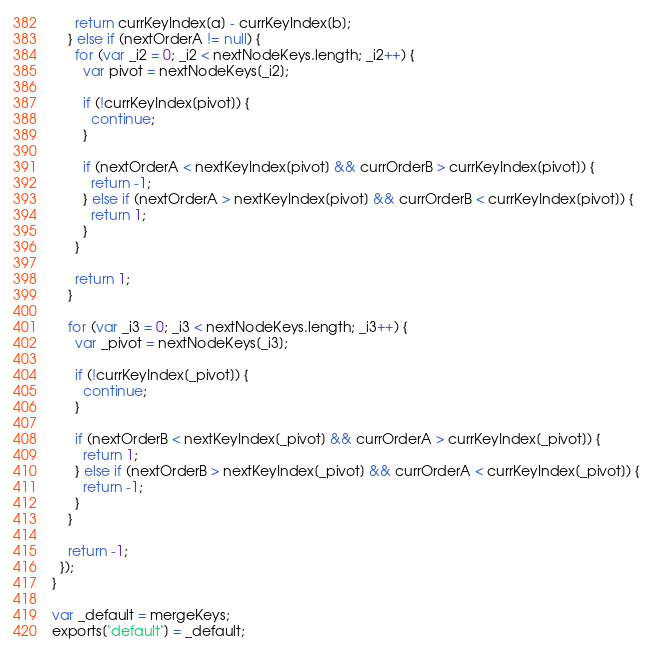Convert code to text. <code><loc_0><loc_0><loc_500><loc_500><_JavaScript_>      return currKeyIndex[a] - currKeyIndex[b];
    } else if (nextOrderA != null) {
      for (var _i2 = 0; _i2 < nextNodeKeys.length; _i2++) {
        var pivot = nextNodeKeys[_i2];

        if (!currKeyIndex[pivot]) {
          continue;
        }

        if (nextOrderA < nextKeyIndex[pivot] && currOrderB > currKeyIndex[pivot]) {
          return -1;
        } else if (nextOrderA > nextKeyIndex[pivot] && currOrderB < currKeyIndex[pivot]) {
          return 1;
        }
      }

      return 1;
    }

    for (var _i3 = 0; _i3 < nextNodeKeys.length; _i3++) {
      var _pivot = nextNodeKeys[_i3];

      if (!currKeyIndex[_pivot]) {
        continue;
      }

      if (nextOrderB < nextKeyIndex[_pivot] && currOrderA > currKeyIndex[_pivot]) {
        return 1;
      } else if (nextOrderB > nextKeyIndex[_pivot] && currOrderA < currKeyIndex[_pivot]) {
        return -1;
      }
    }

    return -1;
  });
}

var _default = mergeKeys;
exports["default"] = _default;</code> 